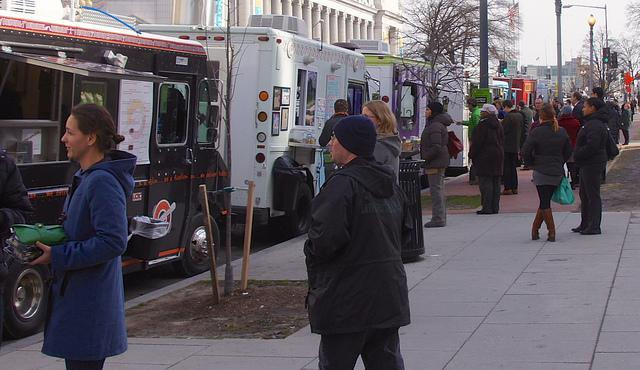What is the color of second vehicle?

Choices:
A) brown
B) pink
C) red
D) white white 